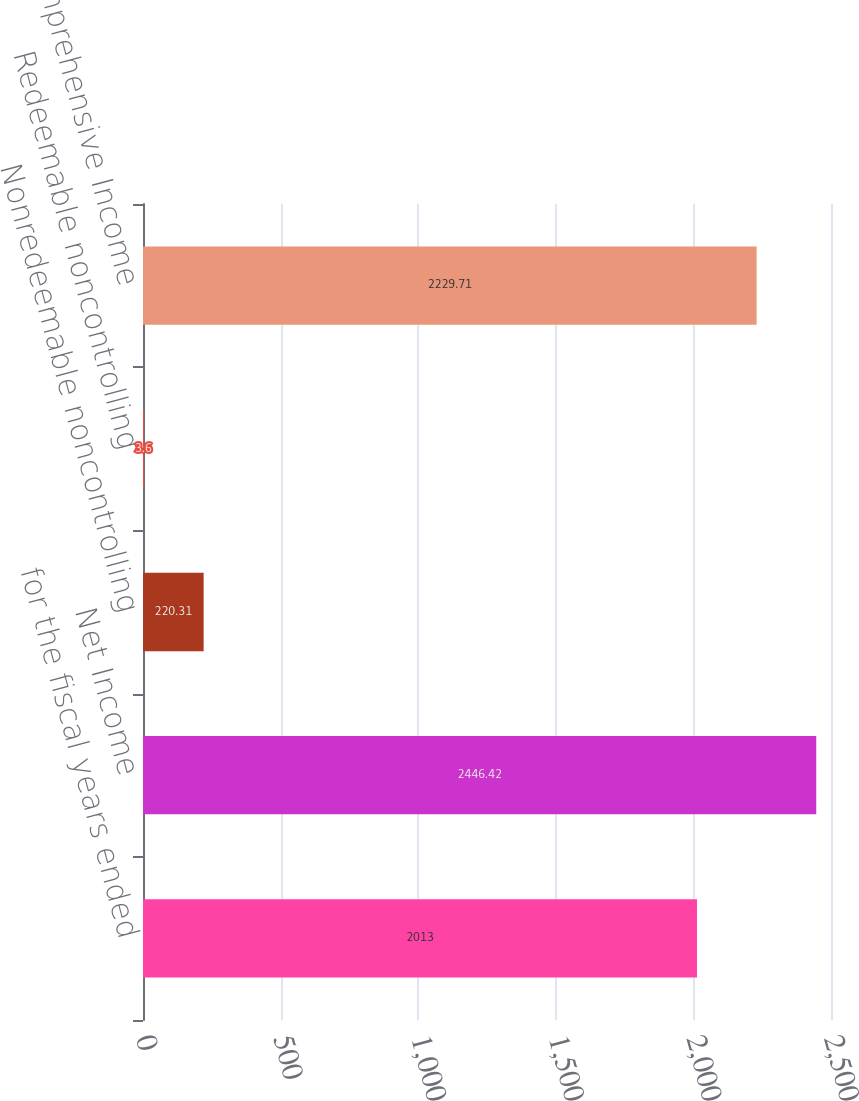Convert chart. <chart><loc_0><loc_0><loc_500><loc_500><bar_chart><fcel>for the fiscal years ended<fcel>Net Income<fcel>Nonredeemable noncontrolling<fcel>Redeemable noncontrolling<fcel>Comprehensive Income<nl><fcel>2013<fcel>2446.42<fcel>220.31<fcel>3.6<fcel>2229.71<nl></chart> 